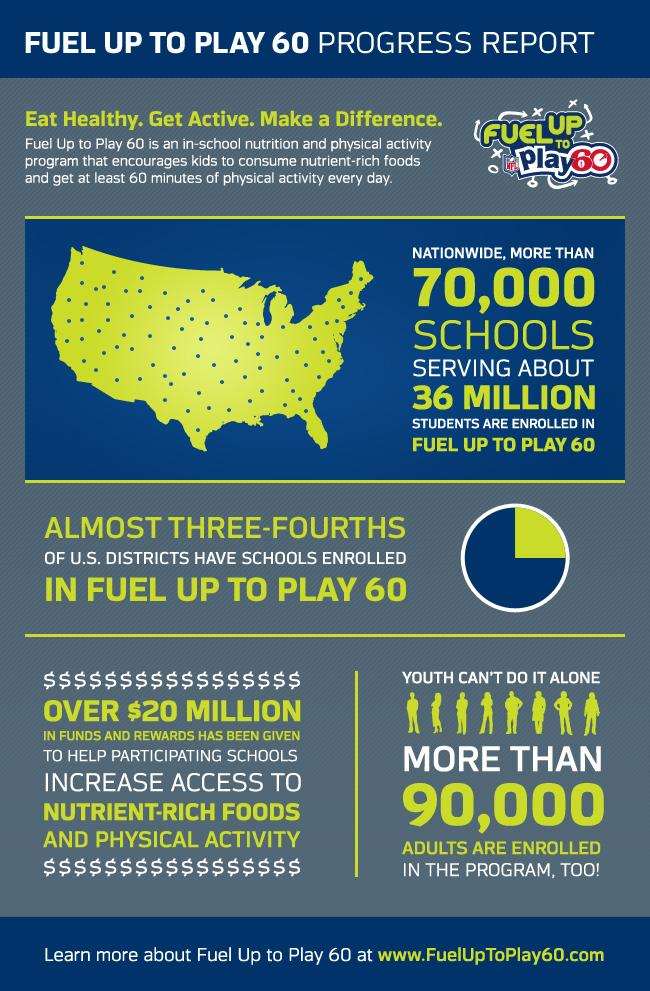Outline some significant characteristics in this image. A significant percentage of schools in the United States have not enrolled in the Fuel Up To Play 60 program. The "Fuel Up To Play 60" program has been joined by over 90,000 grown-ups. 